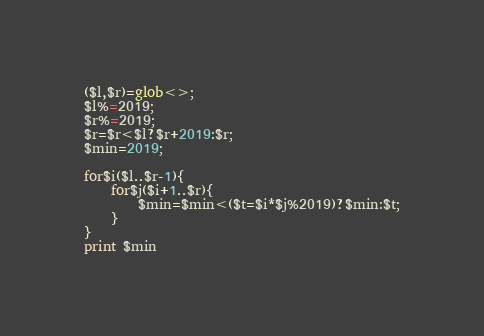Convert code to text. <code><loc_0><loc_0><loc_500><loc_500><_Perl_>($l,$r)=glob<>;
$l%=2019;
$r%=2019;
$r=$r<$l?$r+2019:$r;
$min=2019;

for$i($l..$r-1){
    for$j($i+1..$r){
        $min=$min<($t=$i*$j%2019)?$min:$t;
    }
}
print $min</code> 